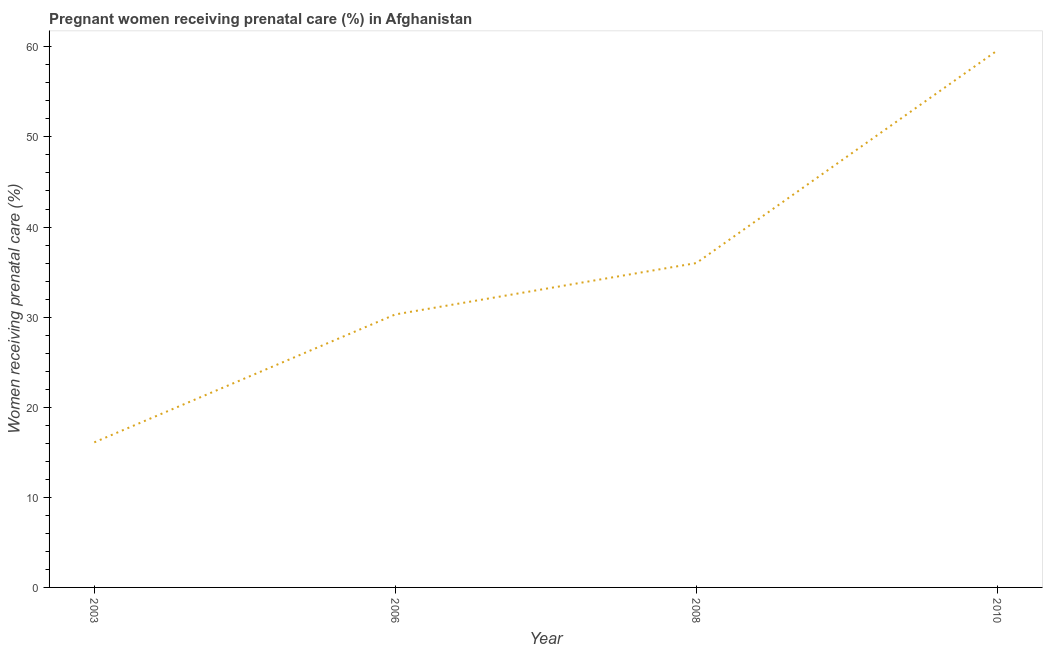What is the percentage of pregnant women receiving prenatal care in 2003?
Make the answer very short. 16.1. Across all years, what is the maximum percentage of pregnant women receiving prenatal care?
Make the answer very short. 59.6. In which year was the percentage of pregnant women receiving prenatal care maximum?
Provide a succinct answer. 2010. What is the sum of the percentage of pregnant women receiving prenatal care?
Ensure brevity in your answer.  142. What is the difference between the percentage of pregnant women receiving prenatal care in 2006 and 2008?
Ensure brevity in your answer.  -5.7. What is the average percentage of pregnant women receiving prenatal care per year?
Give a very brief answer. 35.5. What is the median percentage of pregnant women receiving prenatal care?
Your answer should be compact. 33.15. In how many years, is the percentage of pregnant women receiving prenatal care greater than 12 %?
Your answer should be very brief. 4. What is the ratio of the percentage of pregnant women receiving prenatal care in 2003 to that in 2010?
Your answer should be very brief. 0.27. Is the difference between the percentage of pregnant women receiving prenatal care in 2006 and 2010 greater than the difference between any two years?
Give a very brief answer. No. What is the difference between the highest and the second highest percentage of pregnant women receiving prenatal care?
Offer a terse response. 23.6. What is the difference between the highest and the lowest percentage of pregnant women receiving prenatal care?
Provide a succinct answer. 43.5. Does the percentage of pregnant women receiving prenatal care monotonically increase over the years?
Offer a terse response. Yes. How many lines are there?
Offer a very short reply. 1. What is the difference between two consecutive major ticks on the Y-axis?
Offer a very short reply. 10. What is the title of the graph?
Offer a very short reply. Pregnant women receiving prenatal care (%) in Afghanistan. What is the label or title of the Y-axis?
Provide a succinct answer. Women receiving prenatal care (%). What is the Women receiving prenatal care (%) of 2003?
Your response must be concise. 16.1. What is the Women receiving prenatal care (%) in 2006?
Ensure brevity in your answer.  30.3. What is the Women receiving prenatal care (%) of 2008?
Give a very brief answer. 36. What is the Women receiving prenatal care (%) of 2010?
Provide a short and direct response. 59.6. What is the difference between the Women receiving prenatal care (%) in 2003 and 2006?
Ensure brevity in your answer.  -14.2. What is the difference between the Women receiving prenatal care (%) in 2003 and 2008?
Provide a succinct answer. -19.9. What is the difference between the Women receiving prenatal care (%) in 2003 and 2010?
Your answer should be compact. -43.5. What is the difference between the Women receiving prenatal care (%) in 2006 and 2010?
Keep it short and to the point. -29.3. What is the difference between the Women receiving prenatal care (%) in 2008 and 2010?
Make the answer very short. -23.6. What is the ratio of the Women receiving prenatal care (%) in 2003 to that in 2006?
Provide a short and direct response. 0.53. What is the ratio of the Women receiving prenatal care (%) in 2003 to that in 2008?
Provide a short and direct response. 0.45. What is the ratio of the Women receiving prenatal care (%) in 2003 to that in 2010?
Provide a succinct answer. 0.27. What is the ratio of the Women receiving prenatal care (%) in 2006 to that in 2008?
Offer a terse response. 0.84. What is the ratio of the Women receiving prenatal care (%) in 2006 to that in 2010?
Offer a very short reply. 0.51. What is the ratio of the Women receiving prenatal care (%) in 2008 to that in 2010?
Provide a short and direct response. 0.6. 